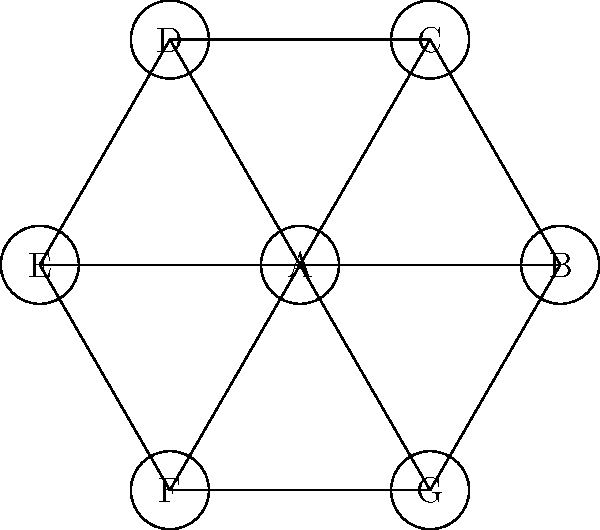In a multicultural community, seven different belief systems (represented by nodes A to G) are interconnected based on their philosophical similarities. To promote harmony and avoid conflicts during community discussions, you want to assign colors to each belief system so that no two directly connected systems share the same color. What is the minimum number of colors needed to achieve this, and what does this number represent in the context of graph theory? To solve this problem, we'll use the concept of graph coloring and chromatic number from graph theory. Let's approach this step-by-step:

1. Analyze the graph structure:
   - We have 7 nodes (A to G) representing different belief systems.
   - Each node is connected to 3 other nodes.
   - The graph forms a wheel structure with node A at the center.

2. Consider the coloring constraints:
   - Adjacent nodes (connected by an edge) must have different colors.
   - We want to minimize the number of colors used.

3. Color the graph:
   - Start with the central node A. Assign it color 1.
   - The outer nodes (B to G) form a cycle of 6 nodes.
   - In a cycle with an even number of nodes, we need 2 colors alternating.
   - However, each of these nodes is also connected to A, so we need a third color.

4. Minimum coloring:
   - Color A: 1
   - Color B, D, F: 2
   - Color C, E, G: 3

5. Verify:
   - No adjacent nodes have the same color.
   - We cannot use fewer than 3 colors due to the wheel structure.

6. Graph theory context:
   - The minimum number of colors needed is called the chromatic number of the graph, denoted as $\chi(G)$.
   - In this case, $\chi(G) = 3$.

7. Interpretation:
   - The chromatic number represents the minimum number of distinct categories or perspectives needed to classify these belief systems without internal conflicts.
Answer: 3 (chromatic number) 